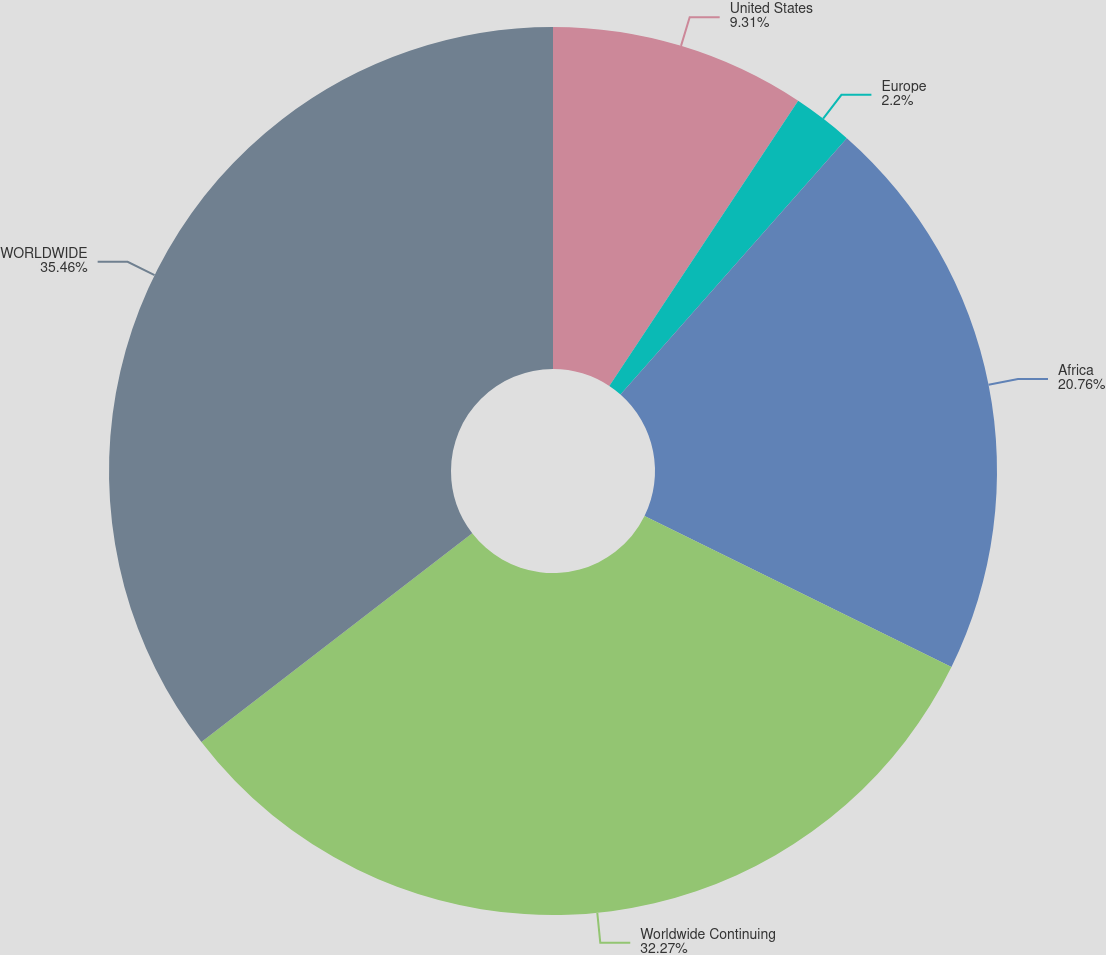<chart> <loc_0><loc_0><loc_500><loc_500><pie_chart><fcel>United States<fcel>Europe<fcel>Africa<fcel>Worldwide Continuing<fcel>WORLDWIDE<nl><fcel>9.31%<fcel>2.2%<fcel>20.76%<fcel>32.27%<fcel>35.45%<nl></chart> 